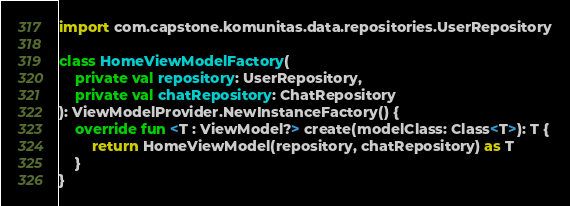Convert code to text. <code><loc_0><loc_0><loc_500><loc_500><_Kotlin_>import com.capstone.komunitas.data.repositories.UserRepository

class HomeViewModelFactory(
    private val repository: UserRepository,
    private val chatRepository: ChatRepository
): ViewModelProvider.NewInstanceFactory() {
    override fun <T : ViewModel?> create(modelClass: Class<T>): T {
        return HomeViewModel(repository, chatRepository) as T
    }
}</code> 